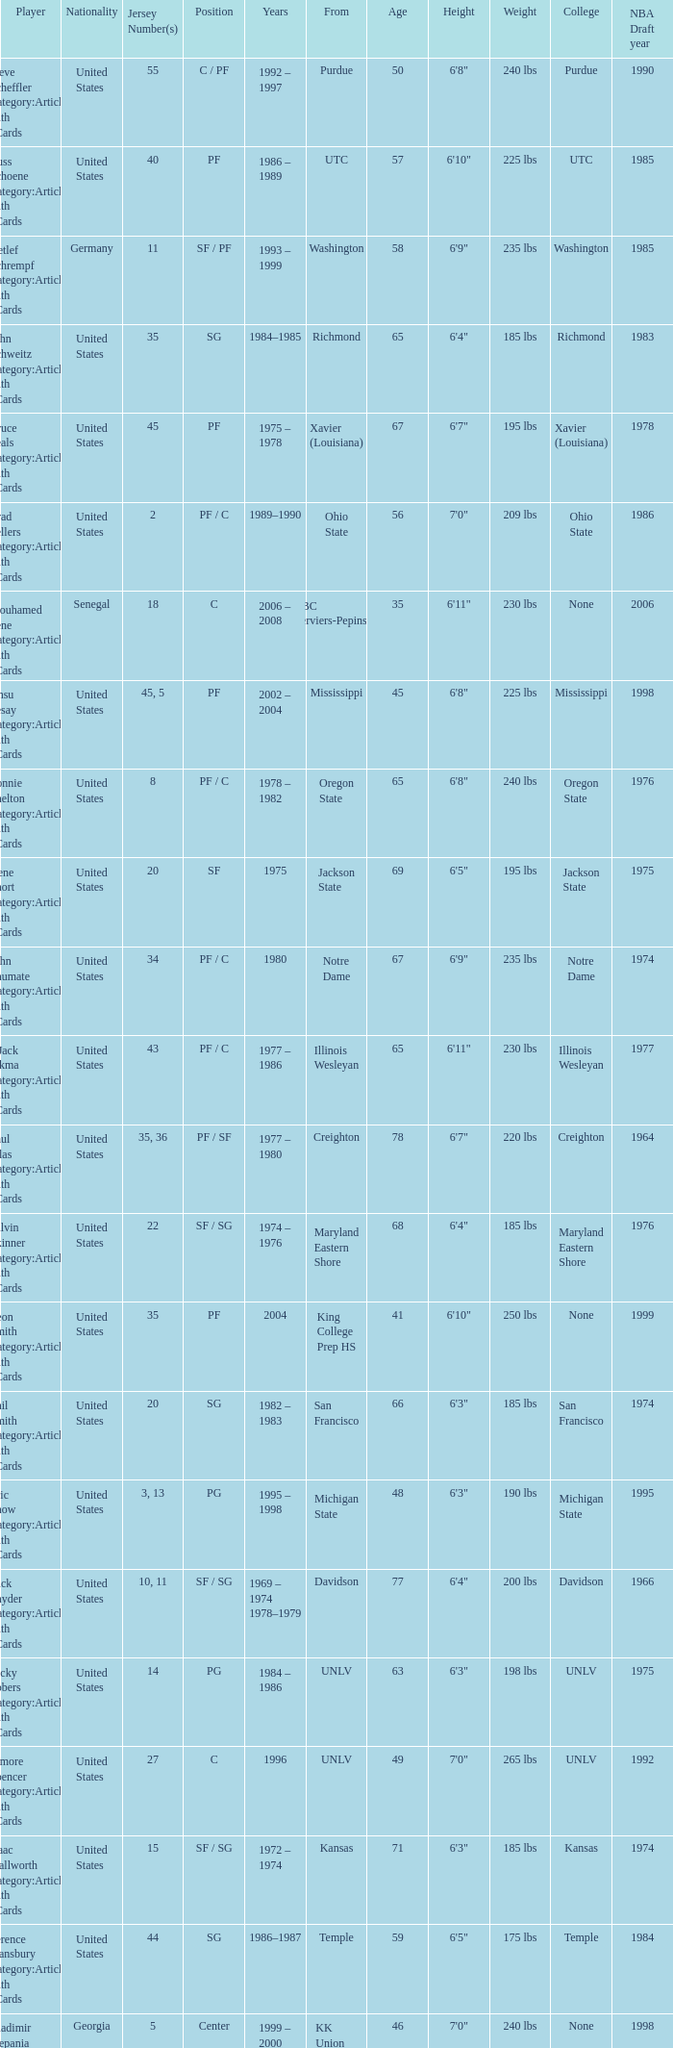What position does the player with jersey number 22 play? SF / SG. 